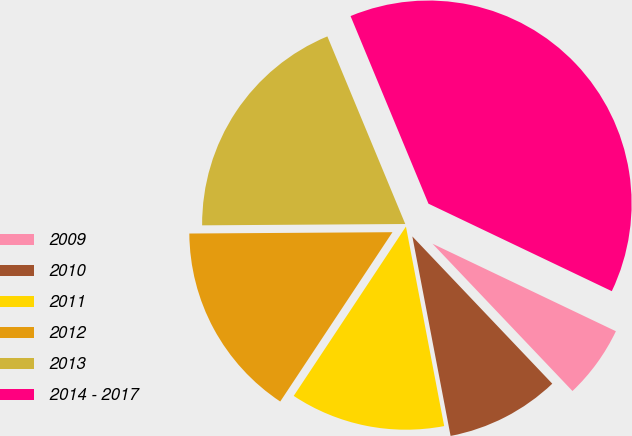Convert chart to OTSL. <chart><loc_0><loc_0><loc_500><loc_500><pie_chart><fcel>2009<fcel>2010<fcel>2011<fcel>2012<fcel>2013<fcel>2014 - 2017<nl><fcel>5.82%<fcel>9.08%<fcel>12.33%<fcel>15.58%<fcel>18.84%<fcel>38.35%<nl></chart> 